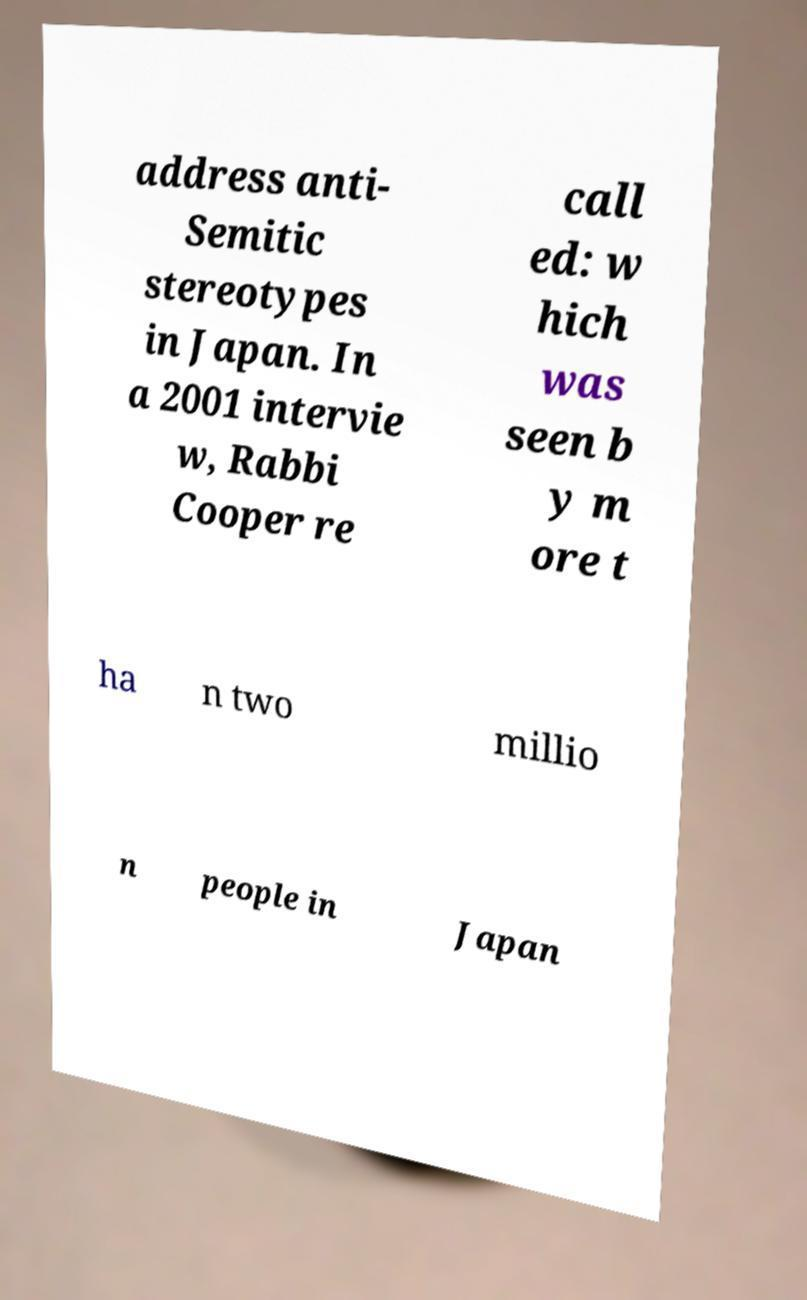Please read and relay the text visible in this image. What does it say? address anti- Semitic stereotypes in Japan. In a 2001 intervie w, Rabbi Cooper re call ed: w hich was seen b y m ore t ha n two millio n people in Japan 